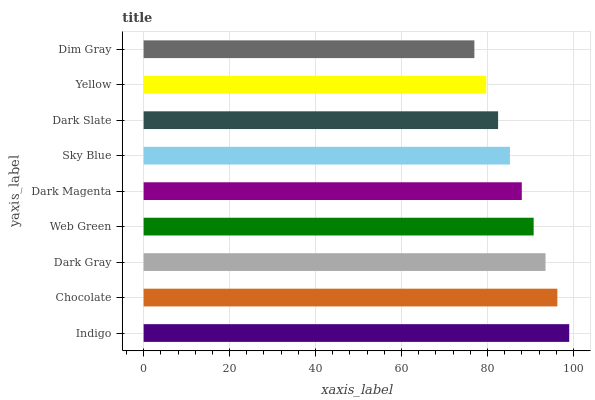Is Dim Gray the minimum?
Answer yes or no. Yes. Is Indigo the maximum?
Answer yes or no. Yes. Is Chocolate the minimum?
Answer yes or no. No. Is Chocolate the maximum?
Answer yes or no. No. Is Indigo greater than Chocolate?
Answer yes or no. Yes. Is Chocolate less than Indigo?
Answer yes or no. Yes. Is Chocolate greater than Indigo?
Answer yes or no. No. Is Indigo less than Chocolate?
Answer yes or no. No. Is Dark Magenta the high median?
Answer yes or no. Yes. Is Dark Magenta the low median?
Answer yes or no. Yes. Is Yellow the high median?
Answer yes or no. No. Is Web Green the low median?
Answer yes or no. No. 